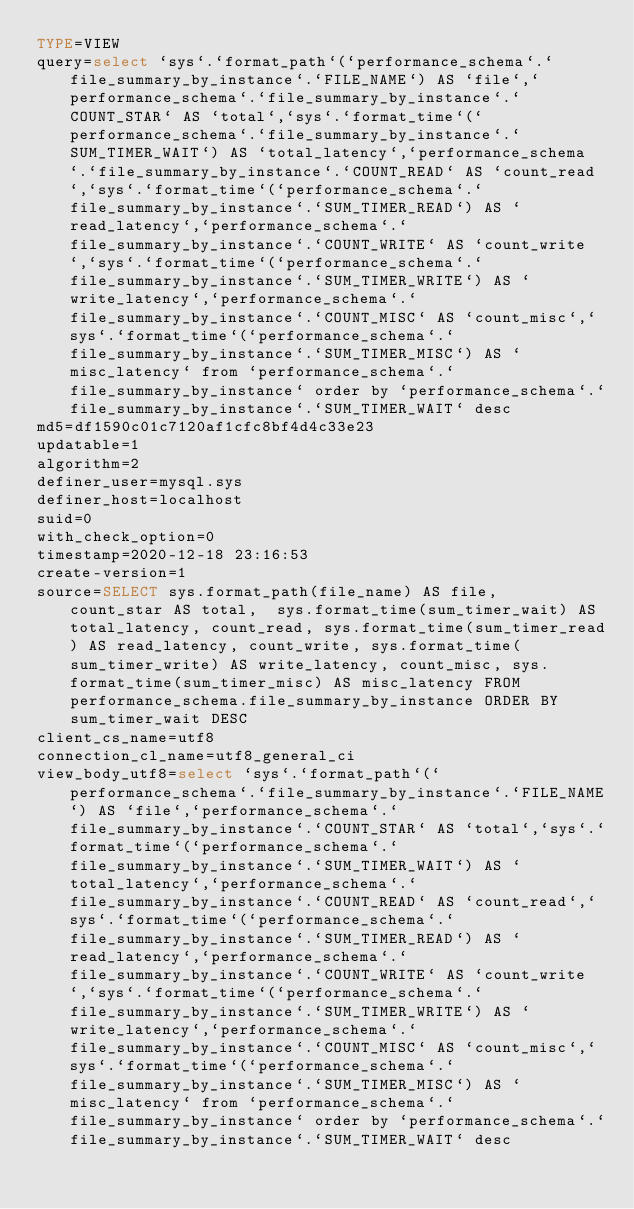Convert code to text. <code><loc_0><loc_0><loc_500><loc_500><_VisualBasic_>TYPE=VIEW
query=select `sys`.`format_path`(`performance_schema`.`file_summary_by_instance`.`FILE_NAME`) AS `file`,`performance_schema`.`file_summary_by_instance`.`COUNT_STAR` AS `total`,`sys`.`format_time`(`performance_schema`.`file_summary_by_instance`.`SUM_TIMER_WAIT`) AS `total_latency`,`performance_schema`.`file_summary_by_instance`.`COUNT_READ` AS `count_read`,`sys`.`format_time`(`performance_schema`.`file_summary_by_instance`.`SUM_TIMER_READ`) AS `read_latency`,`performance_schema`.`file_summary_by_instance`.`COUNT_WRITE` AS `count_write`,`sys`.`format_time`(`performance_schema`.`file_summary_by_instance`.`SUM_TIMER_WRITE`) AS `write_latency`,`performance_schema`.`file_summary_by_instance`.`COUNT_MISC` AS `count_misc`,`sys`.`format_time`(`performance_schema`.`file_summary_by_instance`.`SUM_TIMER_MISC`) AS `misc_latency` from `performance_schema`.`file_summary_by_instance` order by `performance_schema`.`file_summary_by_instance`.`SUM_TIMER_WAIT` desc
md5=df1590c01c7120af1cfc8bf4d4c33e23
updatable=1
algorithm=2
definer_user=mysql.sys
definer_host=localhost
suid=0
with_check_option=0
timestamp=2020-12-18 23:16:53
create-version=1
source=SELECT sys.format_path(file_name) AS file,  count_star AS total,  sys.format_time(sum_timer_wait) AS total_latency, count_read, sys.format_time(sum_timer_read) AS read_latency, count_write, sys.format_time(sum_timer_write) AS write_latency, count_misc, sys.format_time(sum_timer_misc) AS misc_latency FROM performance_schema.file_summary_by_instance ORDER BY sum_timer_wait DESC
client_cs_name=utf8
connection_cl_name=utf8_general_ci
view_body_utf8=select `sys`.`format_path`(`performance_schema`.`file_summary_by_instance`.`FILE_NAME`) AS `file`,`performance_schema`.`file_summary_by_instance`.`COUNT_STAR` AS `total`,`sys`.`format_time`(`performance_schema`.`file_summary_by_instance`.`SUM_TIMER_WAIT`) AS `total_latency`,`performance_schema`.`file_summary_by_instance`.`COUNT_READ` AS `count_read`,`sys`.`format_time`(`performance_schema`.`file_summary_by_instance`.`SUM_TIMER_READ`) AS `read_latency`,`performance_schema`.`file_summary_by_instance`.`COUNT_WRITE` AS `count_write`,`sys`.`format_time`(`performance_schema`.`file_summary_by_instance`.`SUM_TIMER_WRITE`) AS `write_latency`,`performance_schema`.`file_summary_by_instance`.`COUNT_MISC` AS `count_misc`,`sys`.`format_time`(`performance_schema`.`file_summary_by_instance`.`SUM_TIMER_MISC`) AS `misc_latency` from `performance_schema`.`file_summary_by_instance` order by `performance_schema`.`file_summary_by_instance`.`SUM_TIMER_WAIT` desc
</code> 